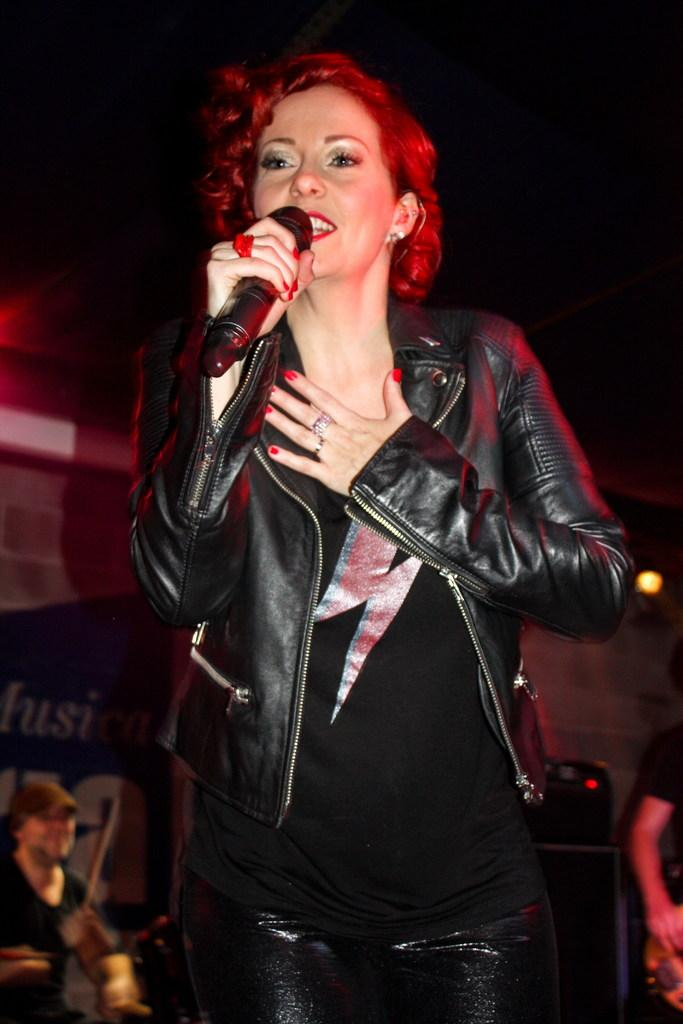Who is the main subject in the image? There is a woman in the image. What is the woman holding in her hand? The woman is holding a microphone in her hand. What is the woman doing in the image? The woman is talking. Can you describe the background of the image? There is a man hitting drums and a person holding a guitar in the background of the image. What can be seen on the wall in the image? There is a light visible on the wall in the image. What time of day is it in the image, based on the hour shown on the clock? There is no clock visible in the image, so we cannot determine the time of day based on an hour. What type of salt is being used by the woman in the image? There is no salt present in the image; the woman is holding a microphone and talking. 